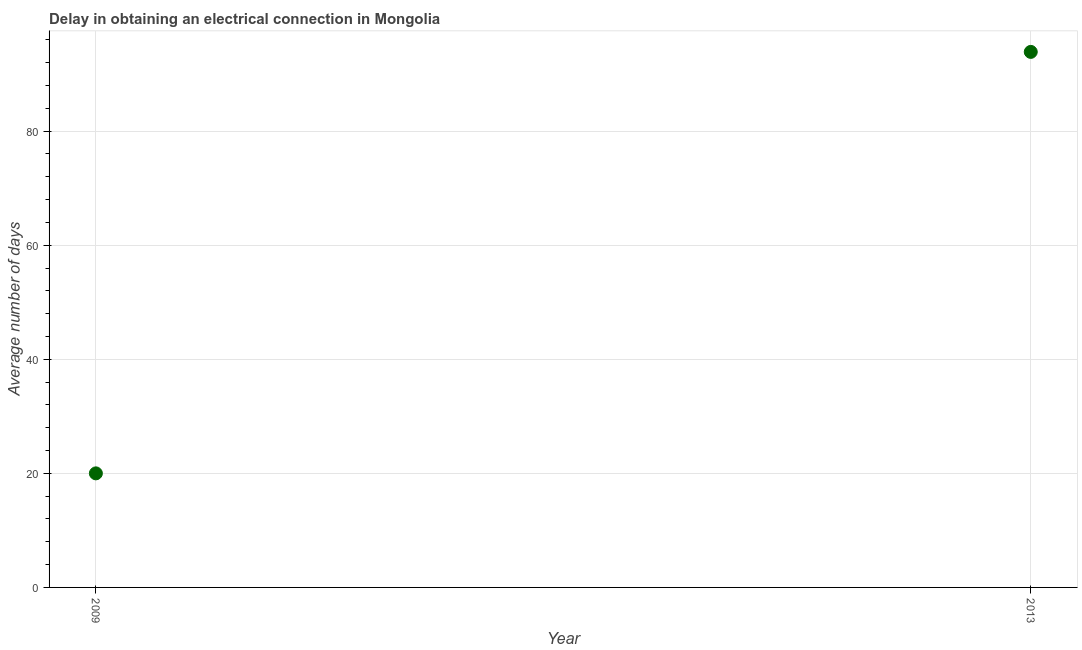What is the dalay in electrical connection in 2013?
Your answer should be very brief. 93.9. Across all years, what is the maximum dalay in electrical connection?
Provide a succinct answer. 93.9. Across all years, what is the minimum dalay in electrical connection?
Offer a very short reply. 20. In which year was the dalay in electrical connection maximum?
Offer a terse response. 2013. What is the sum of the dalay in electrical connection?
Provide a short and direct response. 113.9. What is the difference between the dalay in electrical connection in 2009 and 2013?
Offer a very short reply. -73.9. What is the average dalay in electrical connection per year?
Offer a very short reply. 56.95. What is the median dalay in electrical connection?
Your answer should be compact. 56.95. In how many years, is the dalay in electrical connection greater than 28 days?
Your answer should be compact. 1. What is the ratio of the dalay in electrical connection in 2009 to that in 2013?
Your answer should be very brief. 0.21. Does the dalay in electrical connection monotonically increase over the years?
Give a very brief answer. Yes. How many years are there in the graph?
Your answer should be very brief. 2. Are the values on the major ticks of Y-axis written in scientific E-notation?
Offer a terse response. No. Does the graph contain grids?
Your response must be concise. Yes. What is the title of the graph?
Offer a terse response. Delay in obtaining an electrical connection in Mongolia. What is the label or title of the Y-axis?
Give a very brief answer. Average number of days. What is the Average number of days in 2013?
Offer a very short reply. 93.9. What is the difference between the Average number of days in 2009 and 2013?
Provide a succinct answer. -73.9. What is the ratio of the Average number of days in 2009 to that in 2013?
Offer a terse response. 0.21. 